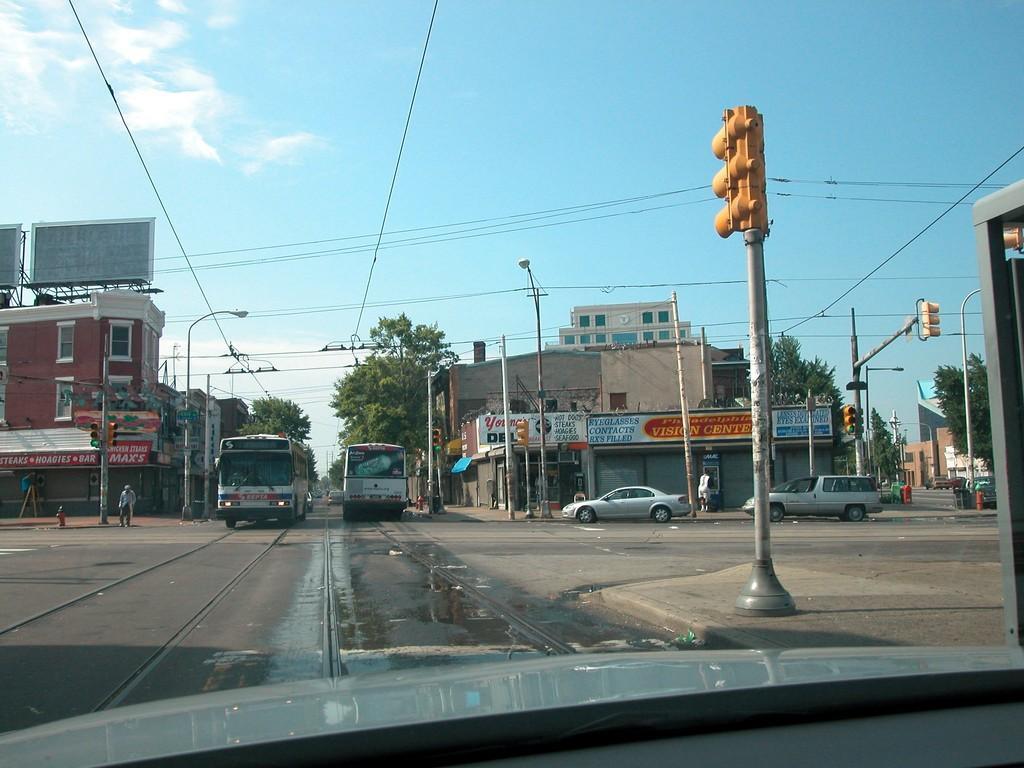Please provide a concise description of this image. In this image we can see few vehicles on the road, there are few buildings, trees, traffic lights and street lights, a person near the traffic light, wires and the sky in the top. 